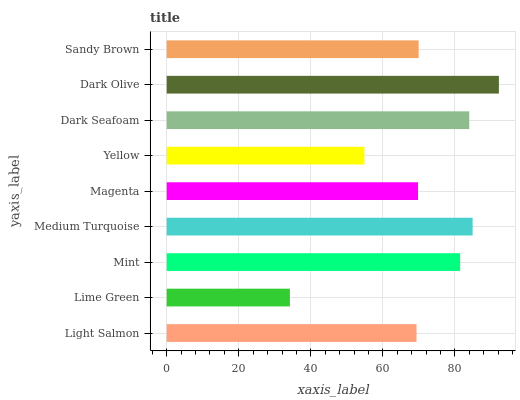Is Lime Green the minimum?
Answer yes or no. Yes. Is Dark Olive the maximum?
Answer yes or no. Yes. Is Mint the minimum?
Answer yes or no. No. Is Mint the maximum?
Answer yes or no. No. Is Mint greater than Lime Green?
Answer yes or no. Yes. Is Lime Green less than Mint?
Answer yes or no. Yes. Is Lime Green greater than Mint?
Answer yes or no. No. Is Mint less than Lime Green?
Answer yes or no. No. Is Sandy Brown the high median?
Answer yes or no. Yes. Is Sandy Brown the low median?
Answer yes or no. Yes. Is Yellow the high median?
Answer yes or no. No. Is Light Salmon the low median?
Answer yes or no. No. 